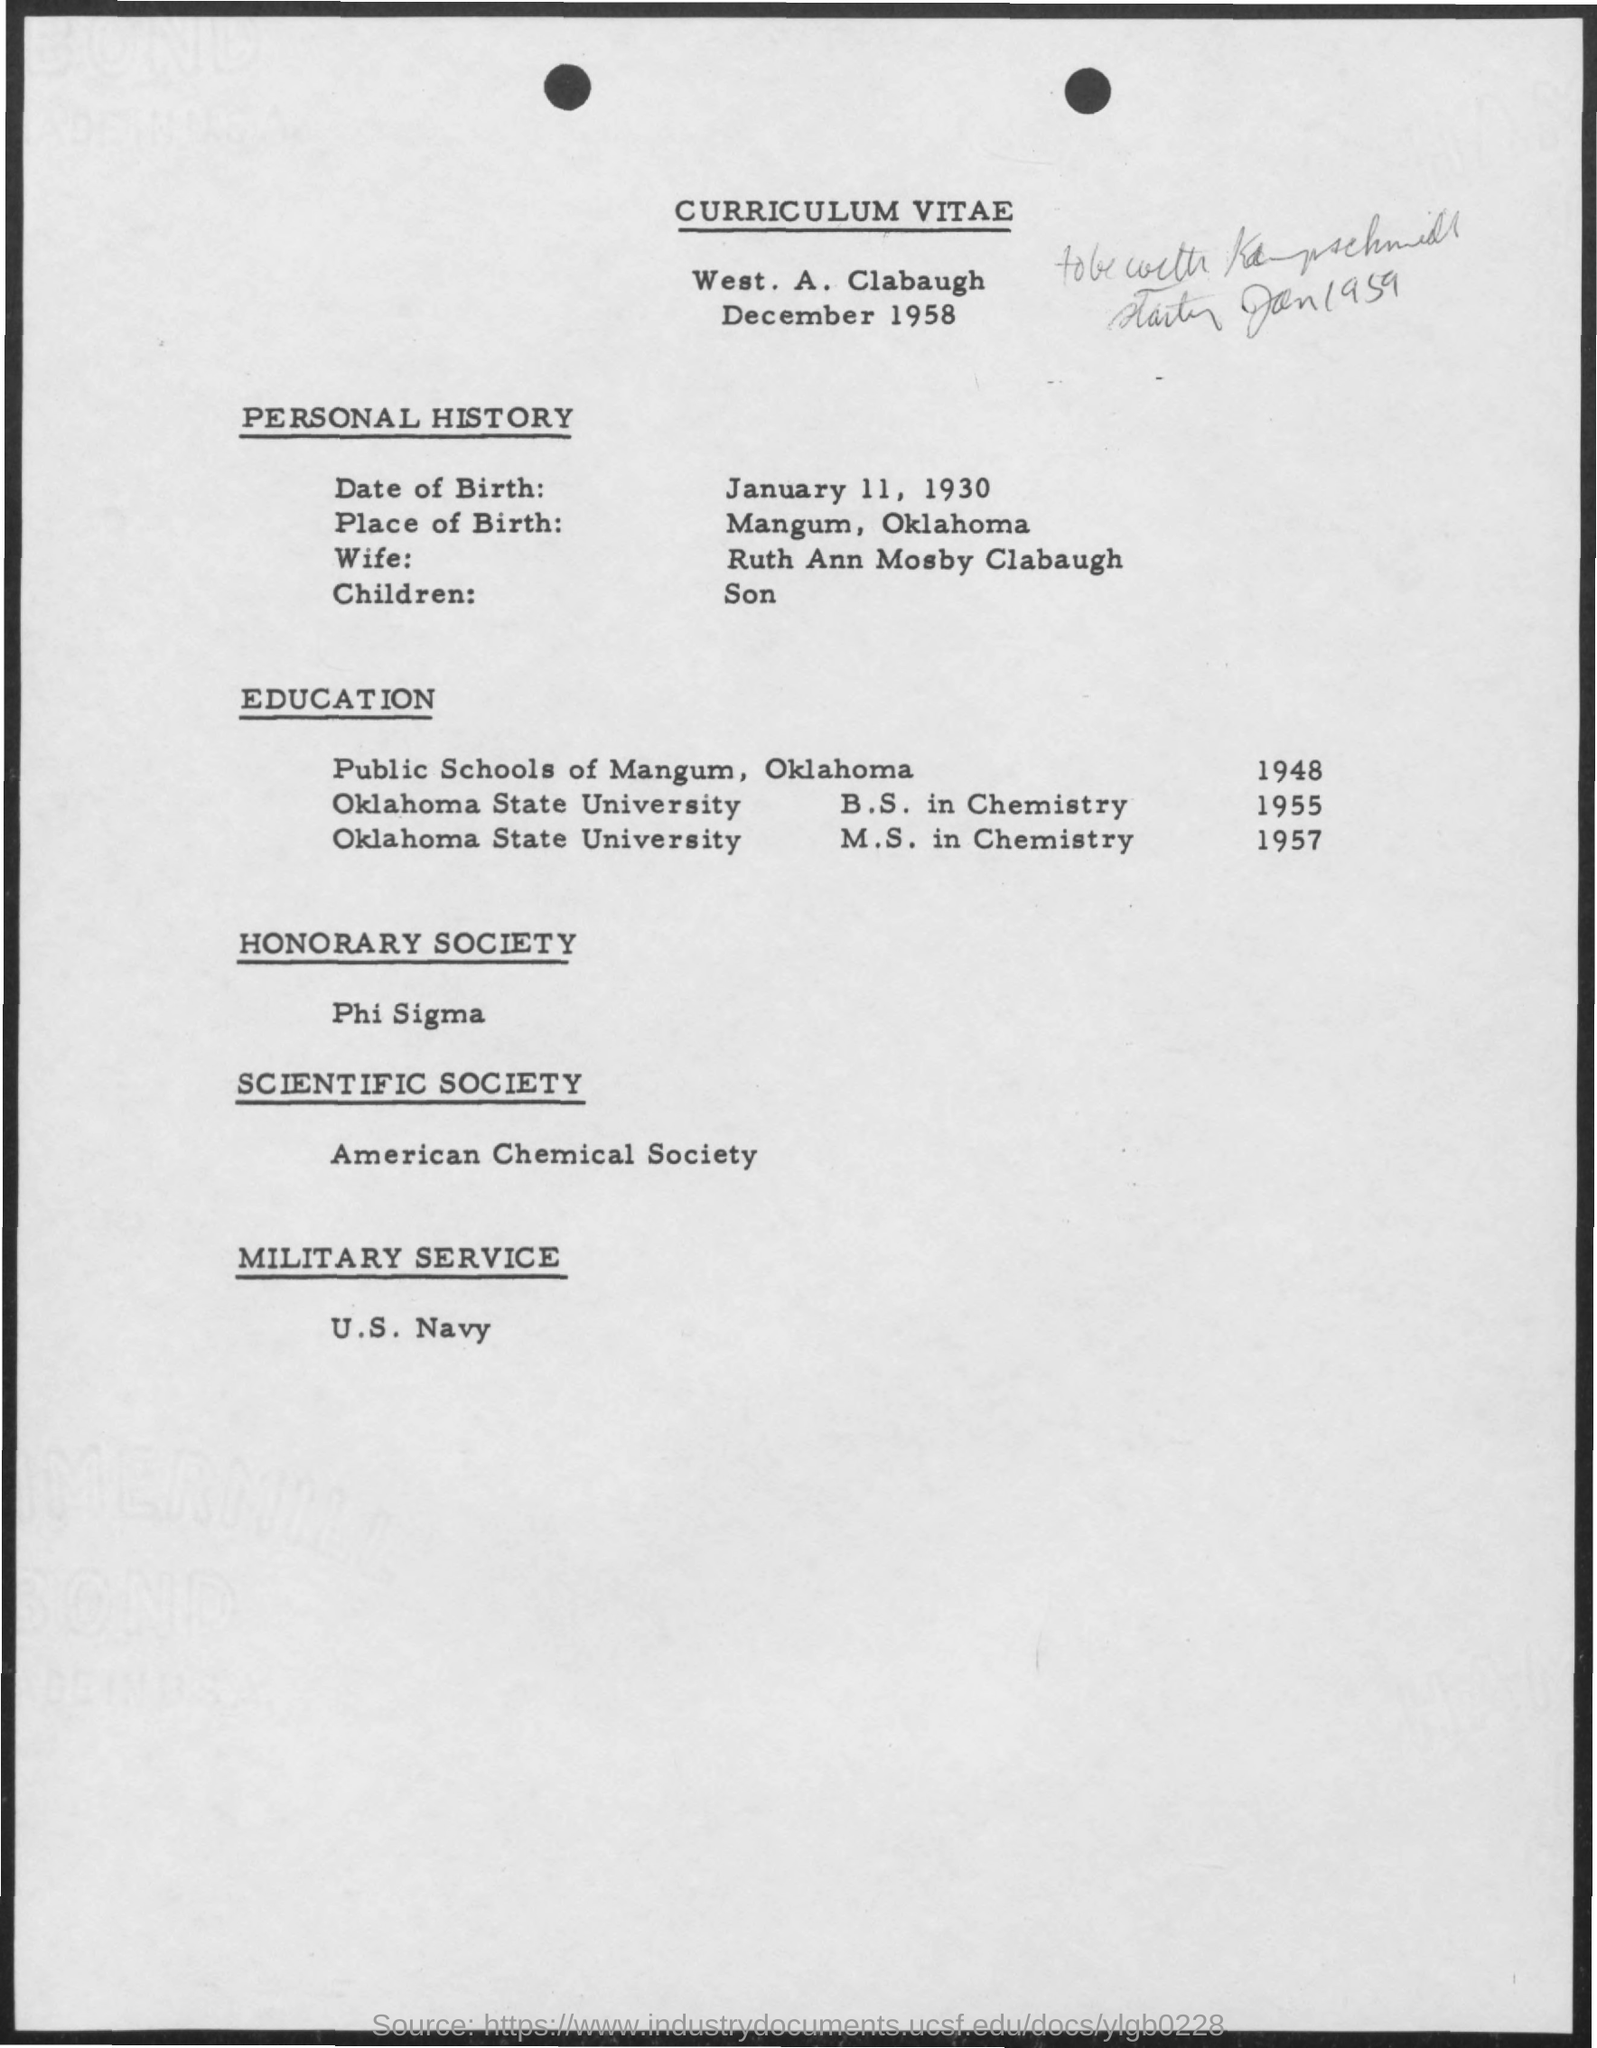Give some essential details in this illustration. The Phi Sigma honorary society was mentioned. The date of birth mentioned in the given page is January 11, 1930. The American Chemical Society is a scientific society that has been mentioned. The place of birth mentioned in the given page is Mangum, Oklahoma. The wife mentioned is Ruth Ann Mosby Clabaugh. 